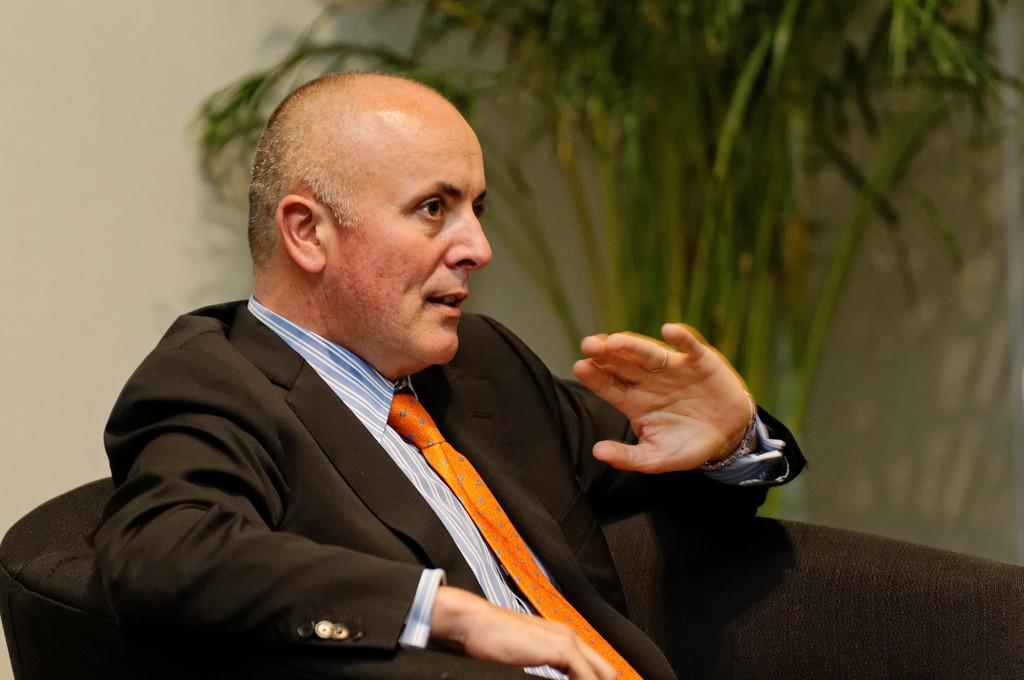What is the man in the image doing? The man is sitting in the image, and it appears that he is talking. What is the man wearing? The man is wearing clothes. What else can be seen in the image besides the man? There is a plant and a wall in the image. How would you describe the background of the image? The background of the image is blurred. What type of sleet is falling in the image? There is no sleet present in the image; it is not raining or snowing. Who is the representative of the man in the image? There is no representative mentioned or depicted in the image; it only shows a man sitting and talking. 